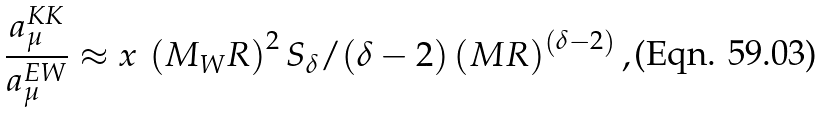<formula> <loc_0><loc_0><loc_500><loc_500>\frac { a _ { \mu } ^ { K K } } { a _ { \mu } ^ { E W } } \approx x \, \left ( M _ { W } R \right ) ^ { 2 } S _ { \delta } / ( \delta - 2 ) \left ( M R \right ) ^ { \left ( \delta - 2 \right ) } ,</formula> 